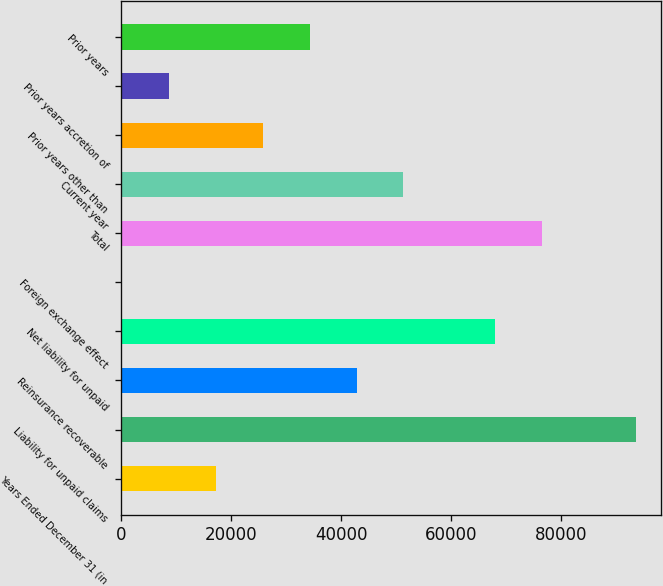Convert chart to OTSL. <chart><loc_0><loc_0><loc_500><loc_500><bar_chart><fcel>Years Ended December 31 (in<fcel>Liability for unpaid claims<fcel>Reinsurance recoverable<fcel>Net liability for unpaid<fcel>Foreign exchange effect<fcel>Total<fcel>Current year<fcel>Prior years other than<fcel>Prior years accretion of<fcel>Prior years<nl><fcel>17178<fcel>93477<fcel>42756<fcel>67899<fcel>126<fcel>76425<fcel>51282<fcel>25704<fcel>8652<fcel>34230<nl></chart> 